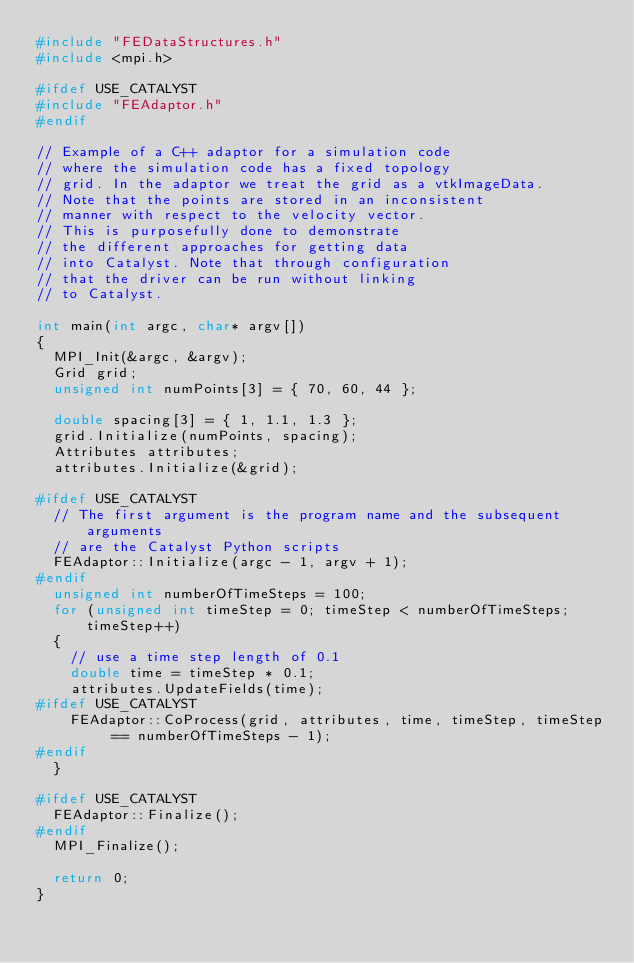<code> <loc_0><loc_0><loc_500><loc_500><_C++_>#include "FEDataStructures.h"
#include <mpi.h>

#ifdef USE_CATALYST
#include "FEAdaptor.h"
#endif

// Example of a C++ adaptor for a simulation code
// where the simulation code has a fixed topology
// grid. In the adaptor we treat the grid as a vtkImageData.
// Note that the points are stored in an inconsistent
// manner with respect to the velocity vector.
// This is purposefully done to demonstrate
// the different approaches for getting data
// into Catalyst. Note that through configuration
// that the driver can be run without linking
// to Catalyst.

int main(int argc, char* argv[])
{
  MPI_Init(&argc, &argv);
  Grid grid;
  unsigned int numPoints[3] = { 70, 60, 44 };

  double spacing[3] = { 1, 1.1, 1.3 };
  grid.Initialize(numPoints, spacing);
  Attributes attributes;
  attributes.Initialize(&grid);

#ifdef USE_CATALYST
  // The first argument is the program name and the subsequent arguments
  // are the Catalyst Python scripts
  FEAdaptor::Initialize(argc - 1, argv + 1);
#endif
  unsigned int numberOfTimeSteps = 100;
  for (unsigned int timeStep = 0; timeStep < numberOfTimeSteps; timeStep++)
  {
    // use a time step length of 0.1
    double time = timeStep * 0.1;
    attributes.UpdateFields(time);
#ifdef USE_CATALYST
    FEAdaptor::CoProcess(grid, attributes, time, timeStep, timeStep == numberOfTimeSteps - 1);
#endif
  }

#ifdef USE_CATALYST
  FEAdaptor::Finalize();
#endif
  MPI_Finalize();

  return 0;
}
</code> 